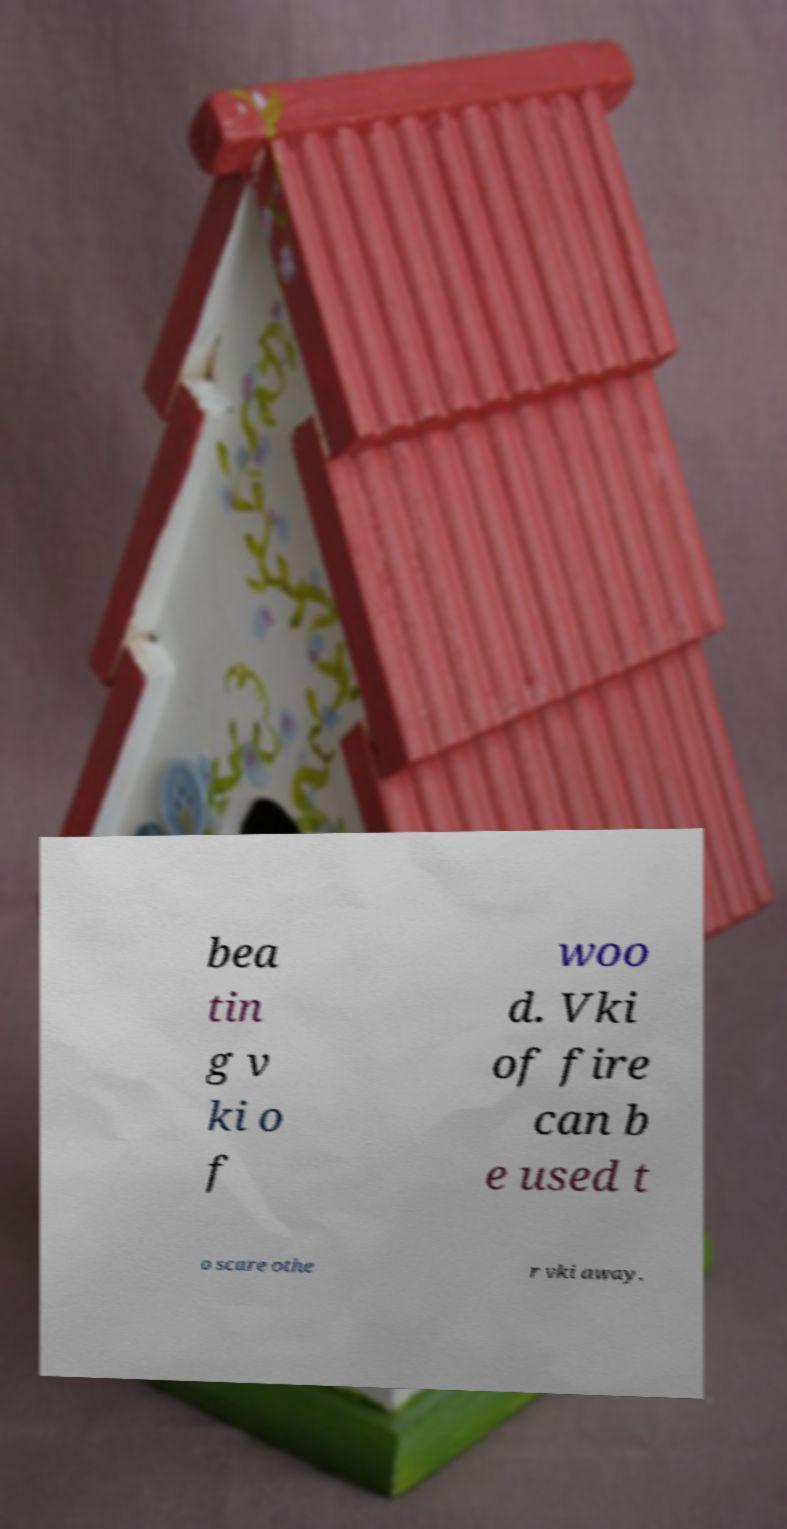Can you read and provide the text displayed in the image?This photo seems to have some interesting text. Can you extract and type it out for me? bea tin g v ki o f woo d. Vki of fire can b e used t o scare othe r vki away. 